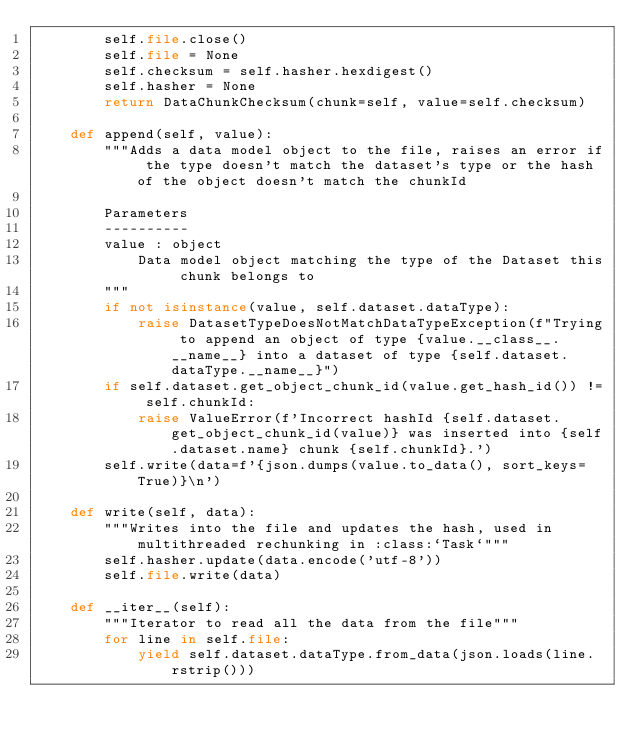<code> <loc_0><loc_0><loc_500><loc_500><_Python_>        self.file.close()
        self.file = None
        self.checksum = self.hasher.hexdigest()
        self.hasher = None
        return DataChunkChecksum(chunk=self, value=self.checksum)

    def append(self, value):
        """Adds a data model object to the file, raises an error if the type doesn't match the dataset's type or the hash of the object doesn't match the chunkId

        Parameters
        ----------
        value : object
            Data model object matching the type of the Dataset this chunk belongs to
        """
        if not isinstance(value, self.dataset.dataType):
            raise DatasetTypeDoesNotMatchDataTypeException(f"Trying to append an object of type {value.__class__.__name__} into a dataset of type {self.dataset.dataType.__name__}")
        if self.dataset.get_object_chunk_id(value.get_hash_id()) != self.chunkId:
            raise ValueError(f'Incorrect hashId {self.dataset.get_object_chunk_id(value)} was inserted into {self.dataset.name} chunk {self.chunkId}.')
        self.write(data=f'{json.dumps(value.to_data(), sort_keys=True)}\n')

    def write(self, data):
        """Writes into the file and updates the hash, used in multithreaded rechunking in :class:`Task`"""
        self.hasher.update(data.encode('utf-8'))
        self.file.write(data)

    def __iter__(self):
        """Iterator to read all the data from the file"""
        for line in self.file:
            yield self.dataset.dataType.from_data(json.loads(line.rstrip()))
</code> 